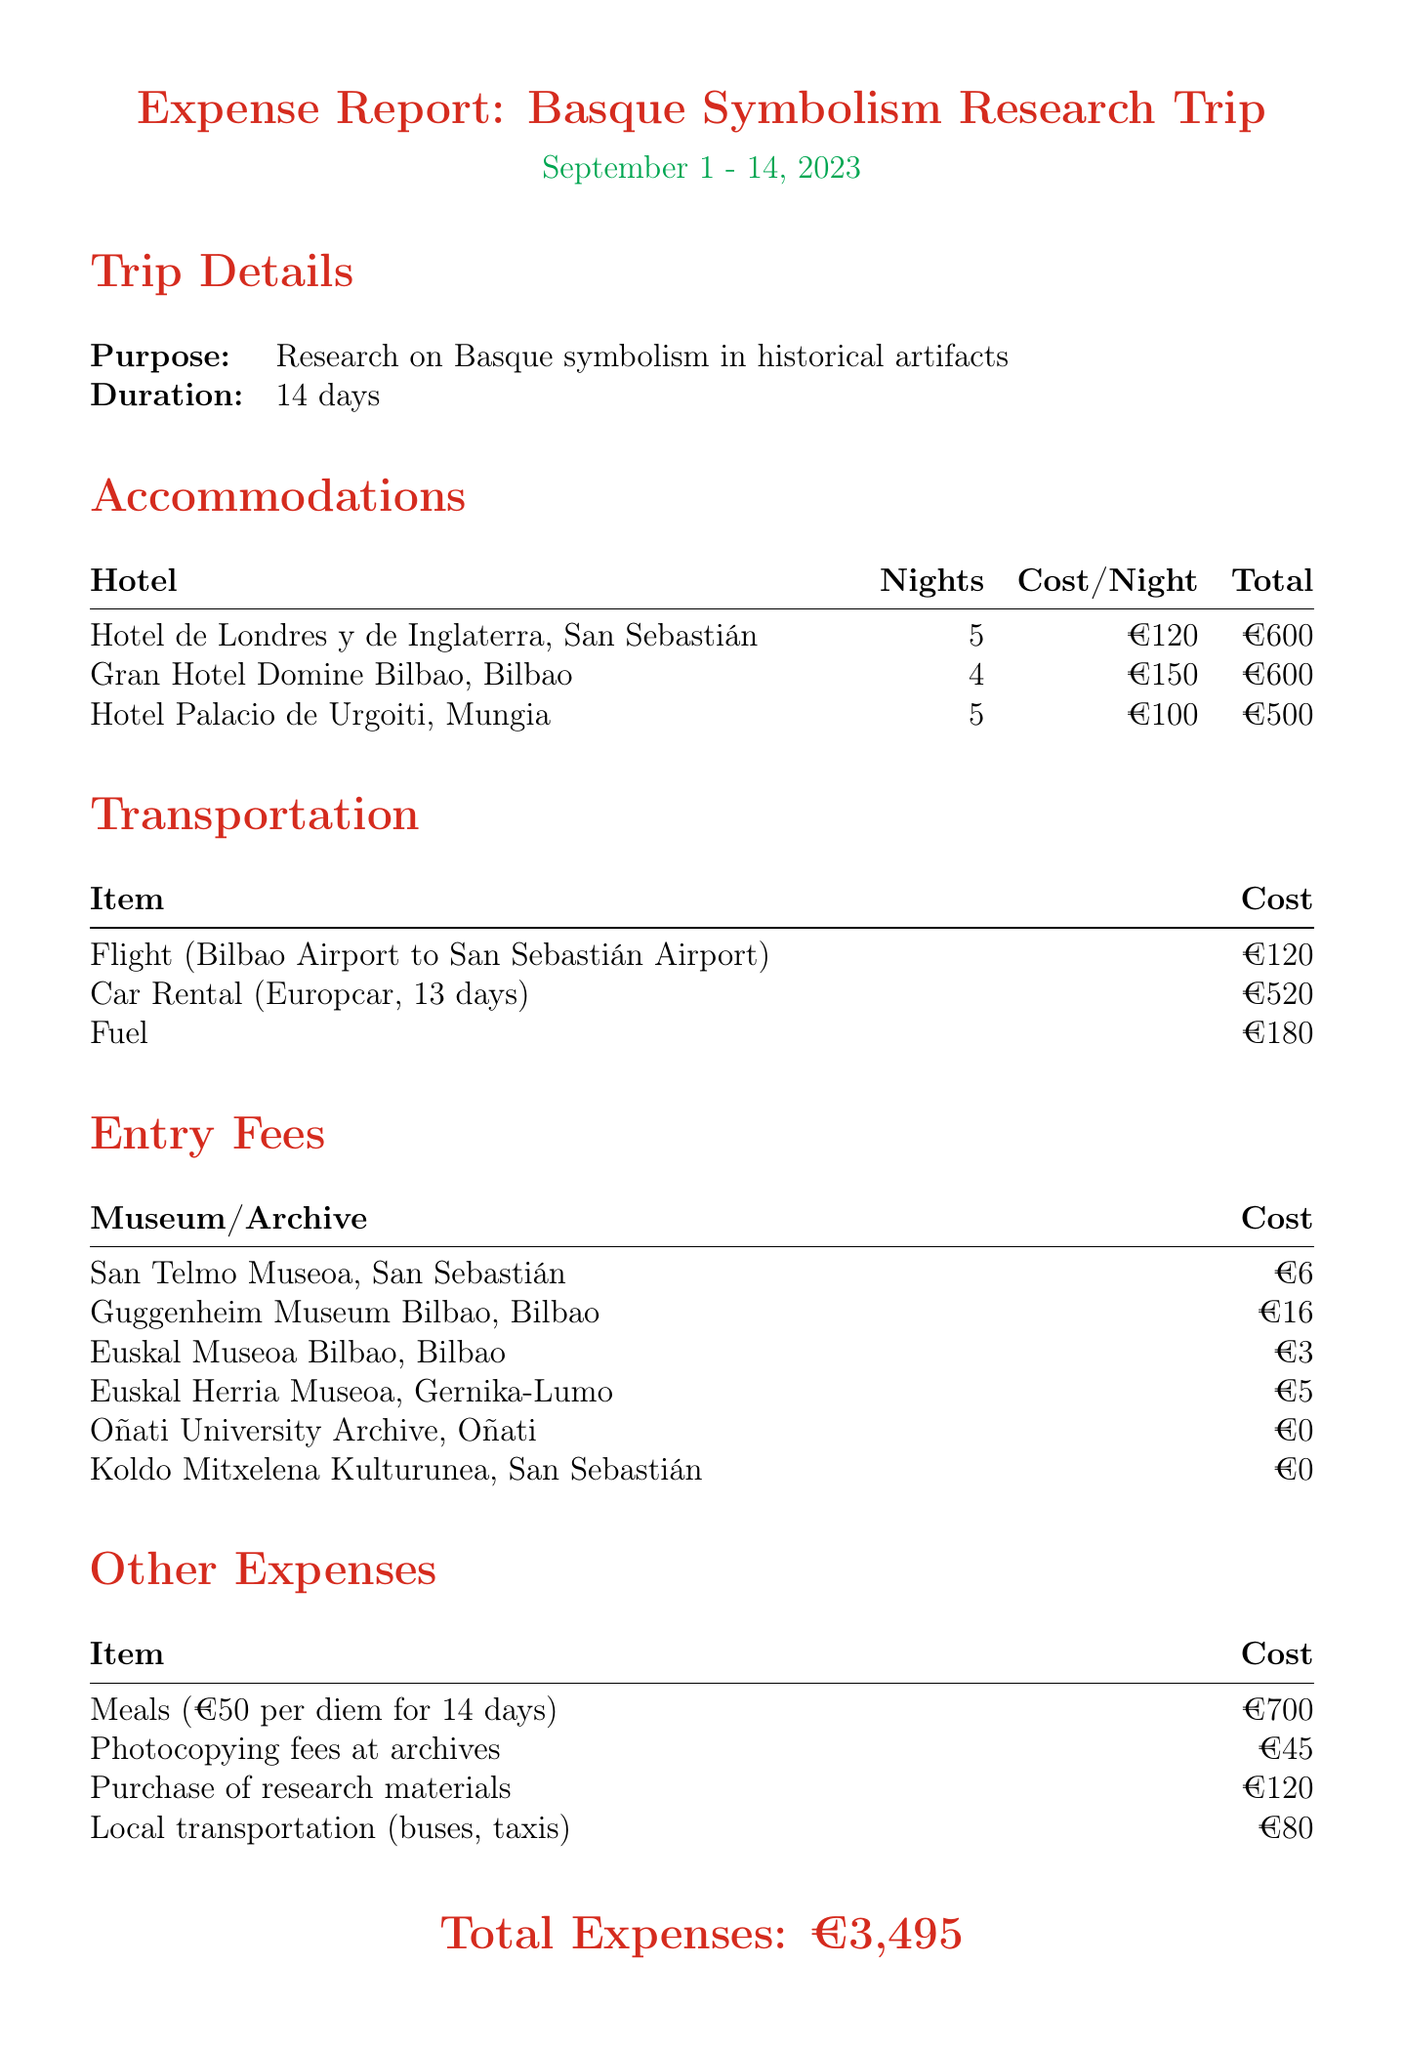What is the purpose of the trip? The purpose is outlined in the trip details section, stating the focus of the research.
Answer: Research on Basque symbolism in historical artifacts How many nights were spent at Hotel Palacio de Urgoiti? The accommodations section notes the number of nights at each hotel.
Answer: 5 What is the total cost for meals? The meals are calculated as €50 per day for 14 days, which is listed under other expenses.
Answer: €700 What was the entry fee for the Guggenheim Museum Bilbao? The entry fees section specifies the cost of visiting various museums, including the Guggenheim.
Answer: €16 How much was spent on transportation? The transportation section lists the costs associated with all transportation items, totaling them up gives the answer.
Answer: €820 What is the total cost of accommodations? By summing the total costs of all hotels listed in the accommodations section, we can determine the total.
Answer: €1,700 Which museum had an entry fee of zero? The entry fees section lists multiple sites, with some having zero entry costs.
Answer: Oñati University Archive What is the duration of the trip? The duration is stated directly in the trip details section.
Answer: 14 days 